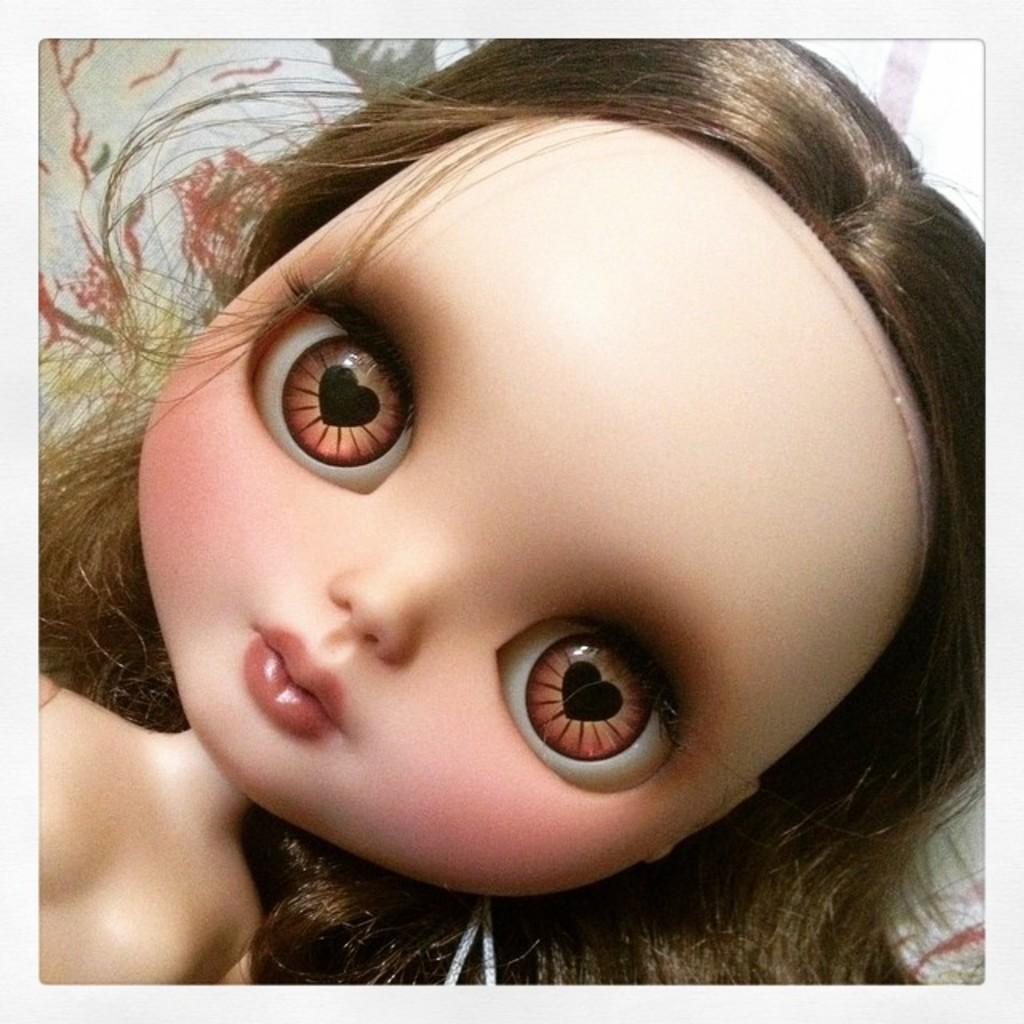What is the main subject in the middle of the image? There is a toy in the middle of the image. Where is the toy located? The toy is lying on a bed. What are the characteristics of the toy's facial features? The toy has big eyes and a short nose. Can you tell me how many elbows the toy has in the image? Toys typically do not have elbows, as they are inanimate objects. The toy in the image does not have any elbows. Is there a banana visible in the image? There is no banana present in the image; it features a toy lying on a bed. 